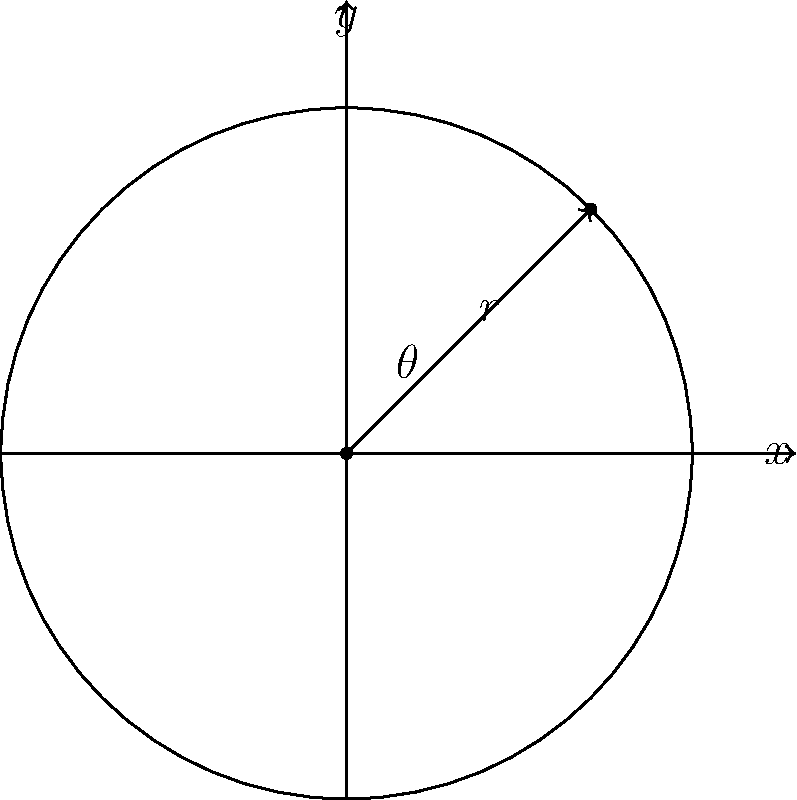In a 2D game, you're developing a rotating power-up object that orbits around a fixed point. The object's position is determined by polar coordinates $(r, \theta)$, where $r = 3$ units and $\theta = \frac{\pi}{4}$ radians. What are the Cartesian coordinates $(x, y)$ of the object? To solve this problem, we need to convert the polar coordinates $(r, \theta)$ to Cartesian coordinates $(x, y)$. We can use the following formulas:

1. $x = r \cos(\theta)$
2. $y = r \sin(\theta)$

Given:
- $r = 3$ units
- $\theta = \frac{\pi}{4}$ radians

Step 1: Calculate $x$
$x = r \cos(\theta) = 3 \cos(\frac{\pi}{4})$

Step 2: Simplify $\cos(\frac{\pi}{4})$
$\cos(\frac{\pi}{4}) = \frac{\sqrt{2}}{2}$

Step 3: Calculate the final value of $x$
$x = 3 \cdot \frac{\sqrt{2}}{2} = \frac{3\sqrt{2}}{2}$

Step 4: Calculate $y$
$y = r \sin(\theta) = 3 \sin(\frac{\pi}{4})$

Step 5: Simplify $\sin(\frac{\pi}{4})$
$\sin(\frac{\pi}{4}) = \frac{\sqrt{2}}{2}$

Step 6: Calculate the final value of $y$
$y = 3 \cdot \frac{\sqrt{2}}{2} = \frac{3\sqrt{2}}{2}$

Therefore, the Cartesian coordinates of the game object are $(\frac{3\sqrt{2}}{2}, \frac{3\sqrt{2}}{2})$.
Answer: $(\frac{3\sqrt{2}}{2}, \frac{3\sqrt{2}}{2})$ 